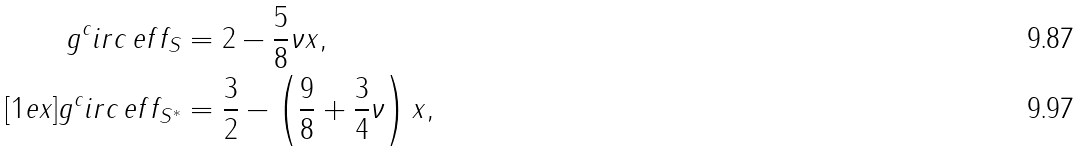Convert formula to latex. <formula><loc_0><loc_0><loc_500><loc_500>g ^ { c } i r c \, e f f _ { S } & = 2 - \frac { 5 } { 8 } \nu x , \\ [ 1 e x ] g ^ { c } i r c \, e f f _ { S ^ { * } } & = \frac { 3 } { 2 } - \left ( \frac { 9 } { 8 } + \frac { 3 } { 4 } \nu \right ) x ,</formula> 